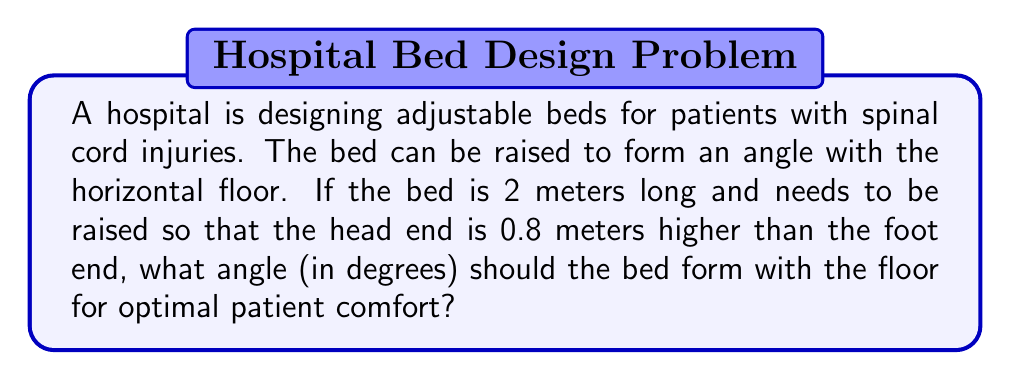Could you help me with this problem? Let's approach this step-by-step using trigonometry:

1) We can visualize this as a right triangle, where:
   - The base is the horizontal distance of the bed
   - The height is the difference in elevation between the head and foot (0.8 m)
   - The hypotenuse is the length of the bed (2 m)

2) We need to find the angle between the bed and the floor. Let's call this angle θ.

3) We can use the sine function to solve for this angle:

   $$\sin θ = \frac{\text{opposite}}{\text{hypotenuse}} = \frac{0.8}{2}$$

4) To solve for θ, we need to take the inverse sine (arcsin) of both sides:

   $$θ = \arcsin(\frac{0.8}{2})$$

5) Using a calculator or computer:

   $$θ ≈ 0.4115 \text{ radians}$$

6) Convert radians to degrees:

   $$θ ≈ 0.4115 \times \frac{180°}{\pi} ≈ 23.58°$$

Therefore, the optimal angle for the adjustable bed is approximately 23.58 degrees.
Answer: $23.58°$ 